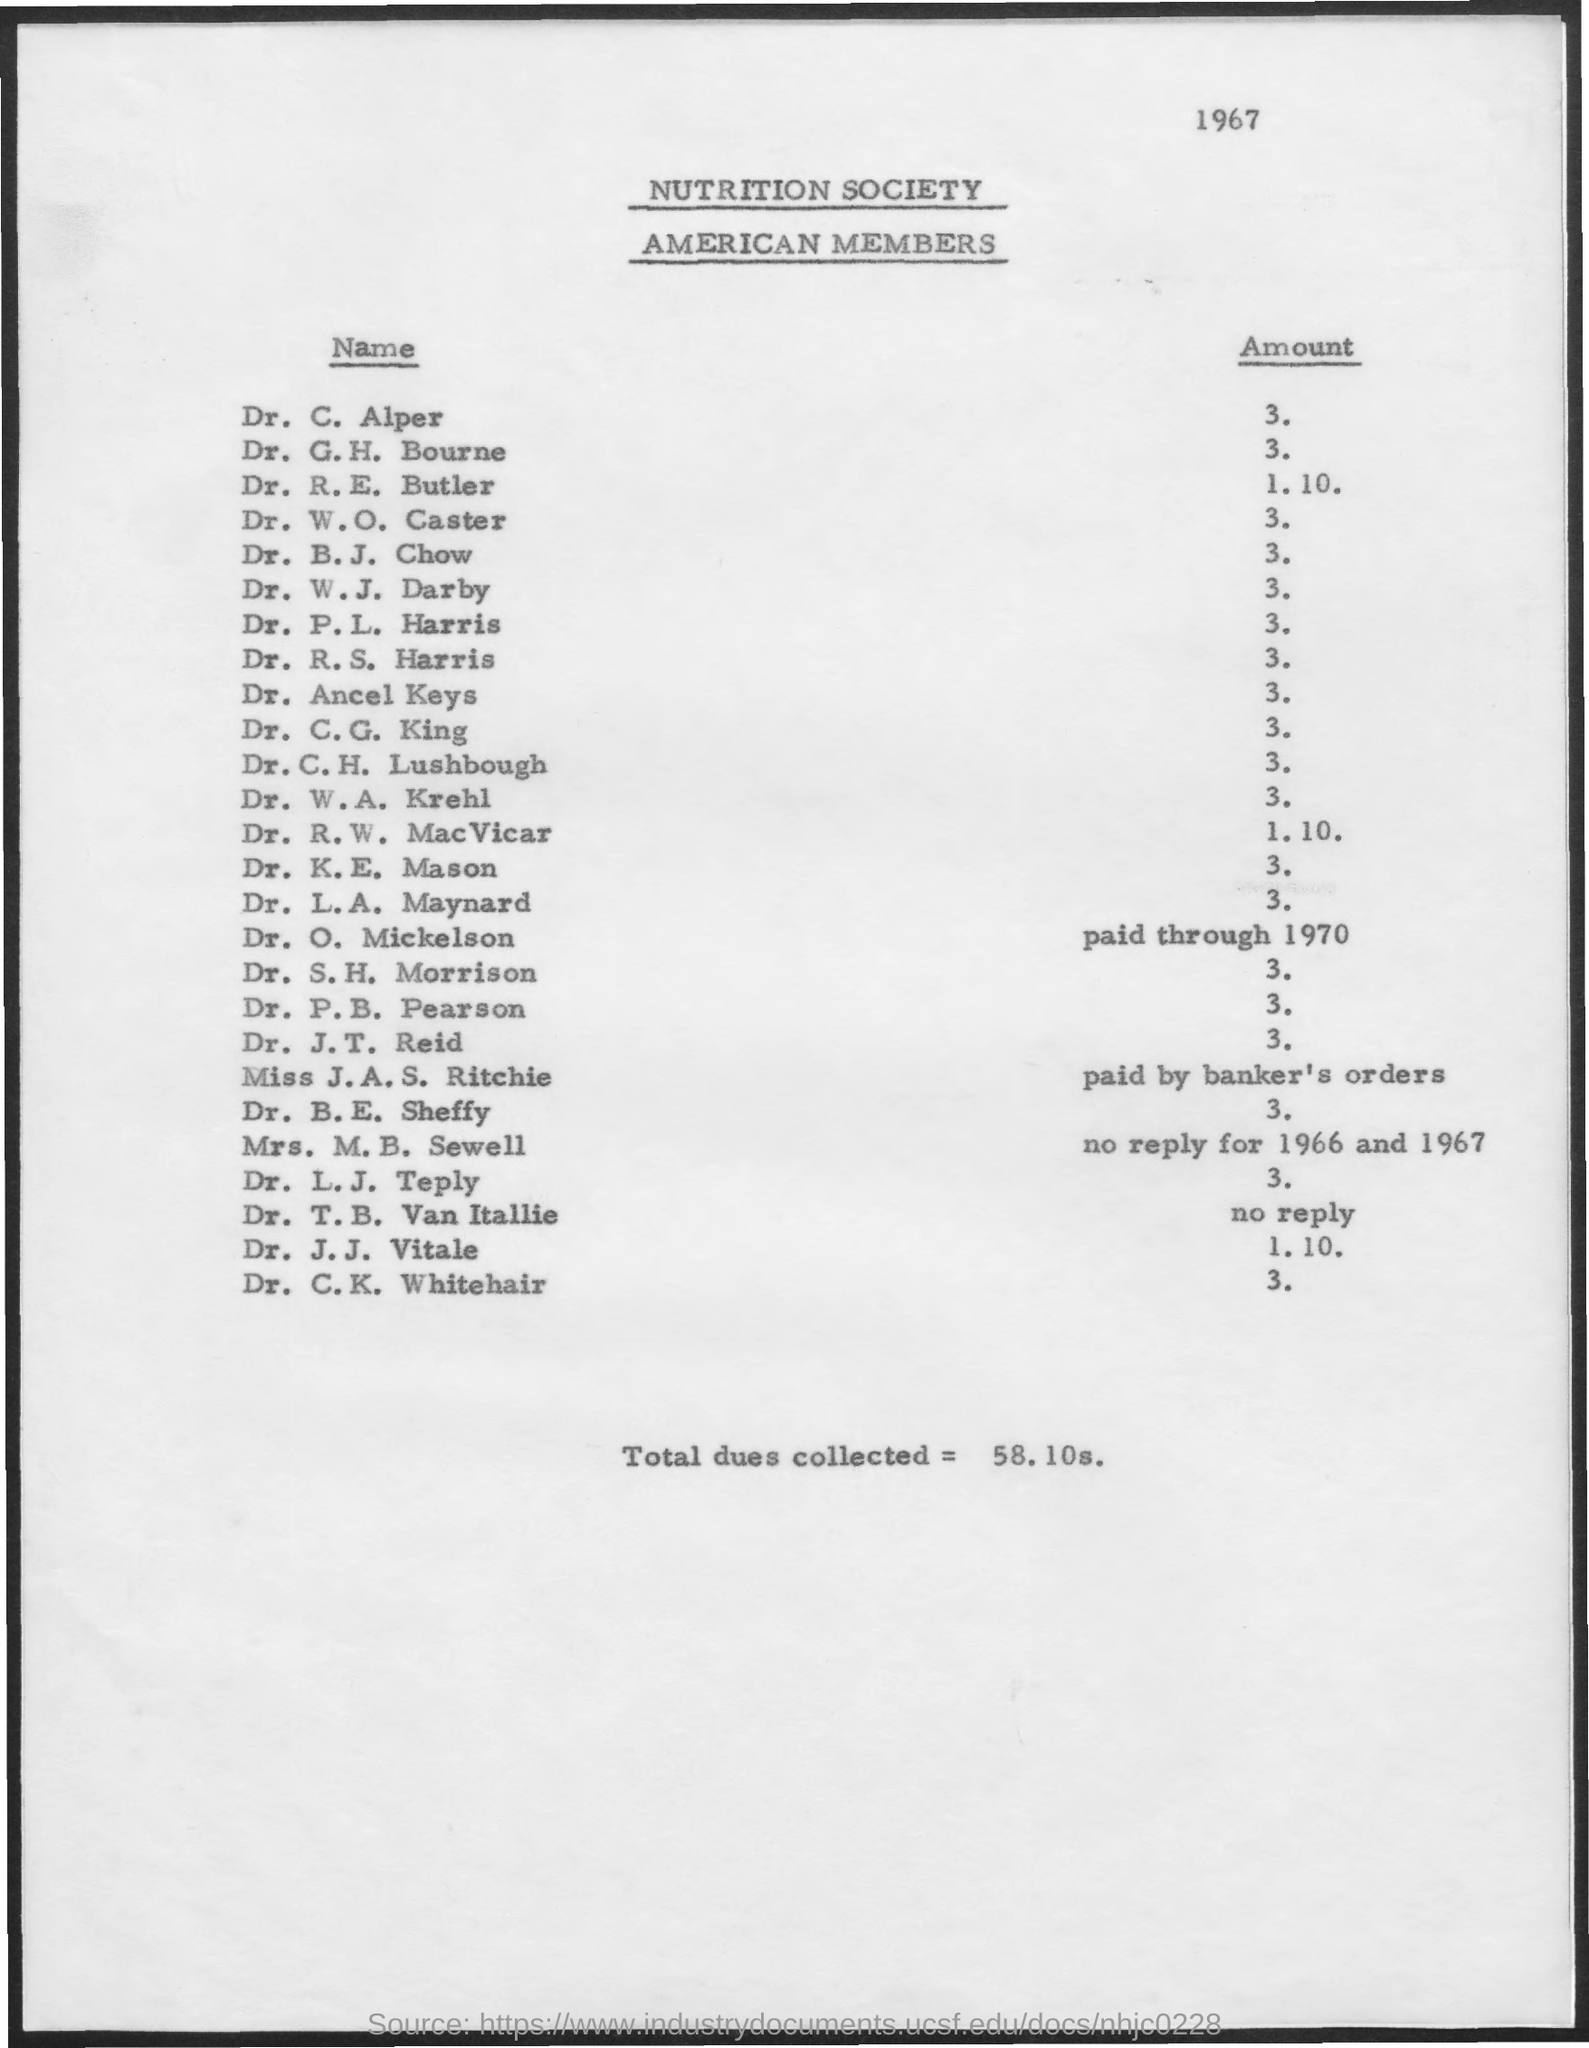Indicate a few pertinent items in this graphic. The amount for Dr. C.G. King is 3000. The amount for Dr. C. Alper is $3. The year mentioned at the top of the page is 1967. The total dues collected is 58.10. The name of the society mentioned is the Nutrition Society. 